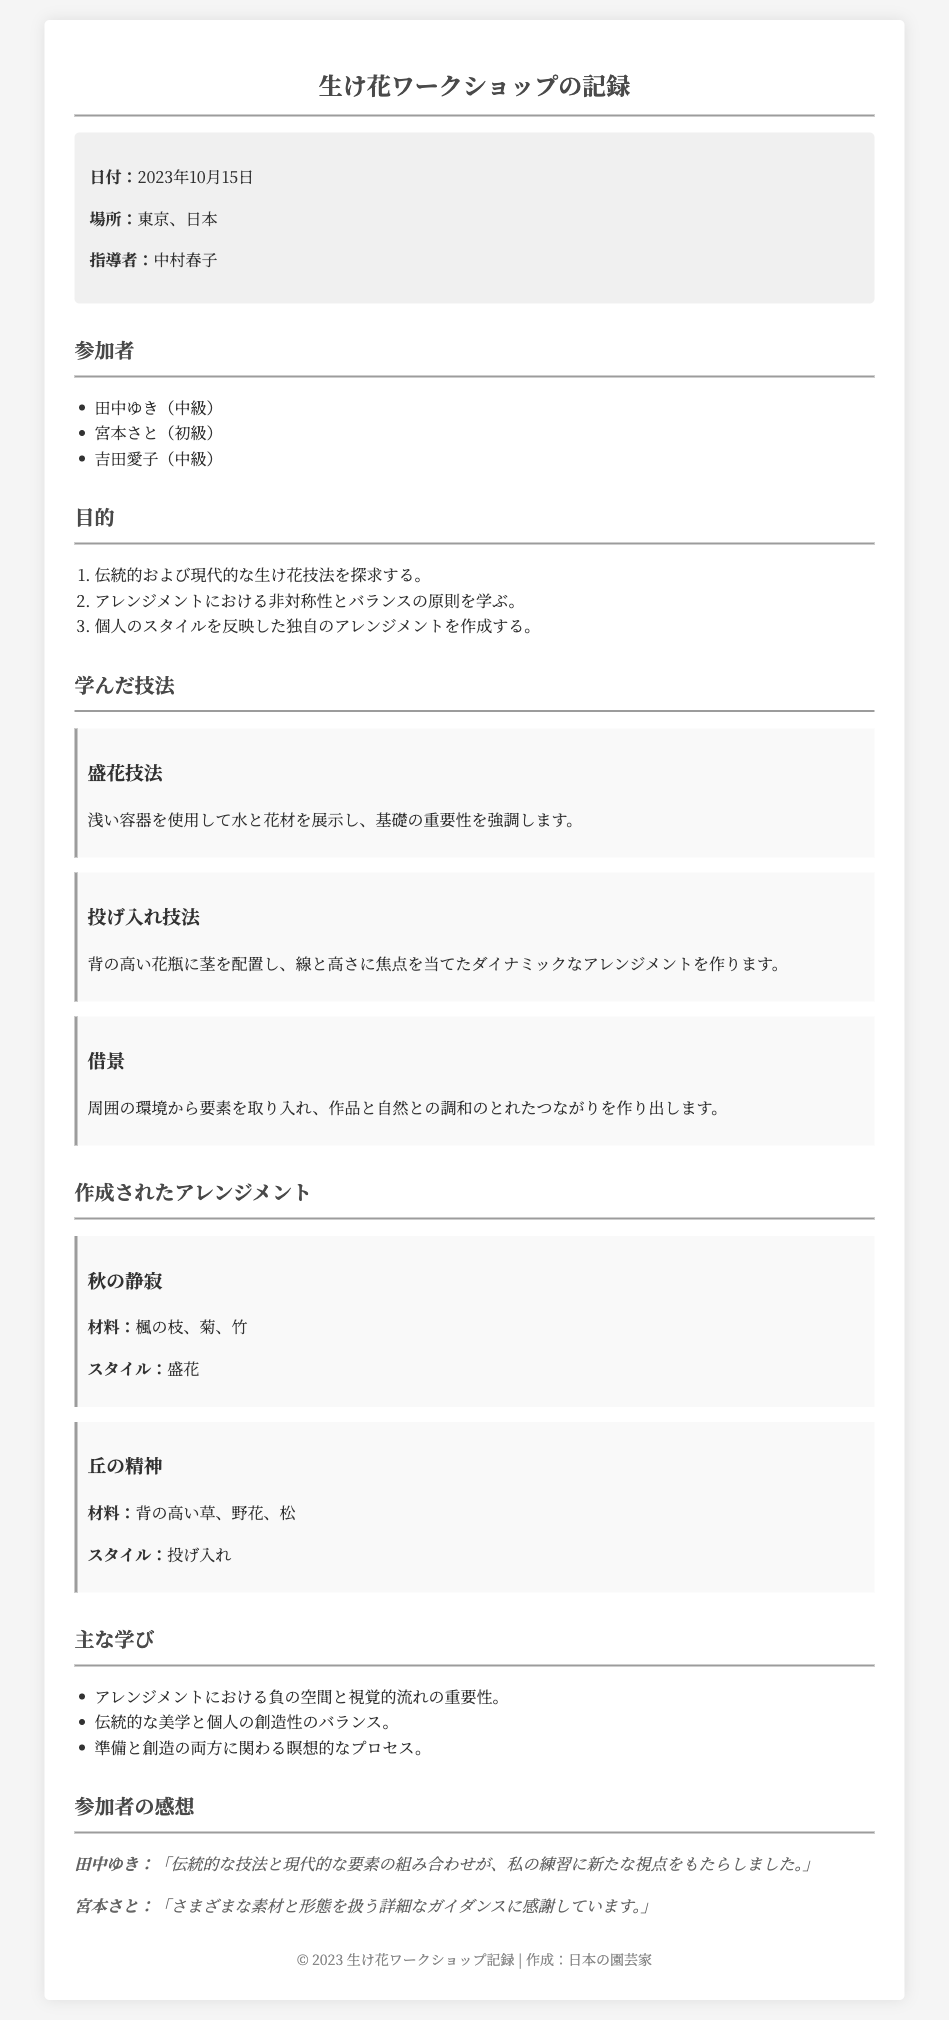何日でしたか？ ワークショップの開催日が明記されており、2023年10月15日です。
Answer: 2023年10月15日 ワークショップの指導者は誰ですか？ 指導者の名前はドキュメント内の特定のセクションに記述されており、中村春子です。
Answer: 中村春子 参加者の人数は？ 参加者のリストが記載されており、3名の参加者がいます。
Answer: 3名 「秋の静寂」に使われた材料は？ アレンジメントの具体的な材料が示されており、楓の枝、菊、竹です。
Answer: 楓の枝、菊、竹 主な学びには何が含まれていますか？ 主な学びのリストがあり、負の空間と視覚的流れの重要性が含まれています。
Answer: 負の空間と視覚的流れの重要性 「借景」はどのような技法ですか？ 学んだ技法の一つとして借景の概要が説明されており、周囲の環境と調和しています。
Answer: 周囲の環境との調和 どこでワークショップが行われましたか？ この情報は文書の冒頭に記載されており、東京、日本と明記されています。
Answer: 東京、日本 田中ゆきの感想は？ 参加者の感想が引用され、田中ゆきが伝統的な技法と現代的な要素について言及しています。
Answer: 伝統的な技法と現代的な要素 このワークショップの目的は？ 目的のリストが示されており、伝統的および現代的な生け花技法を探求することが含まれています。
Answer: 伝統的および現代的な生け花技法を探求 作成されたアレンジメントのスタイルは何ですか？ アレンジメントのスタイルがそれぞれの作品に記載されています。“盛花”と“投げ入れ”です。
Answer: 盛花、投げ入れ 